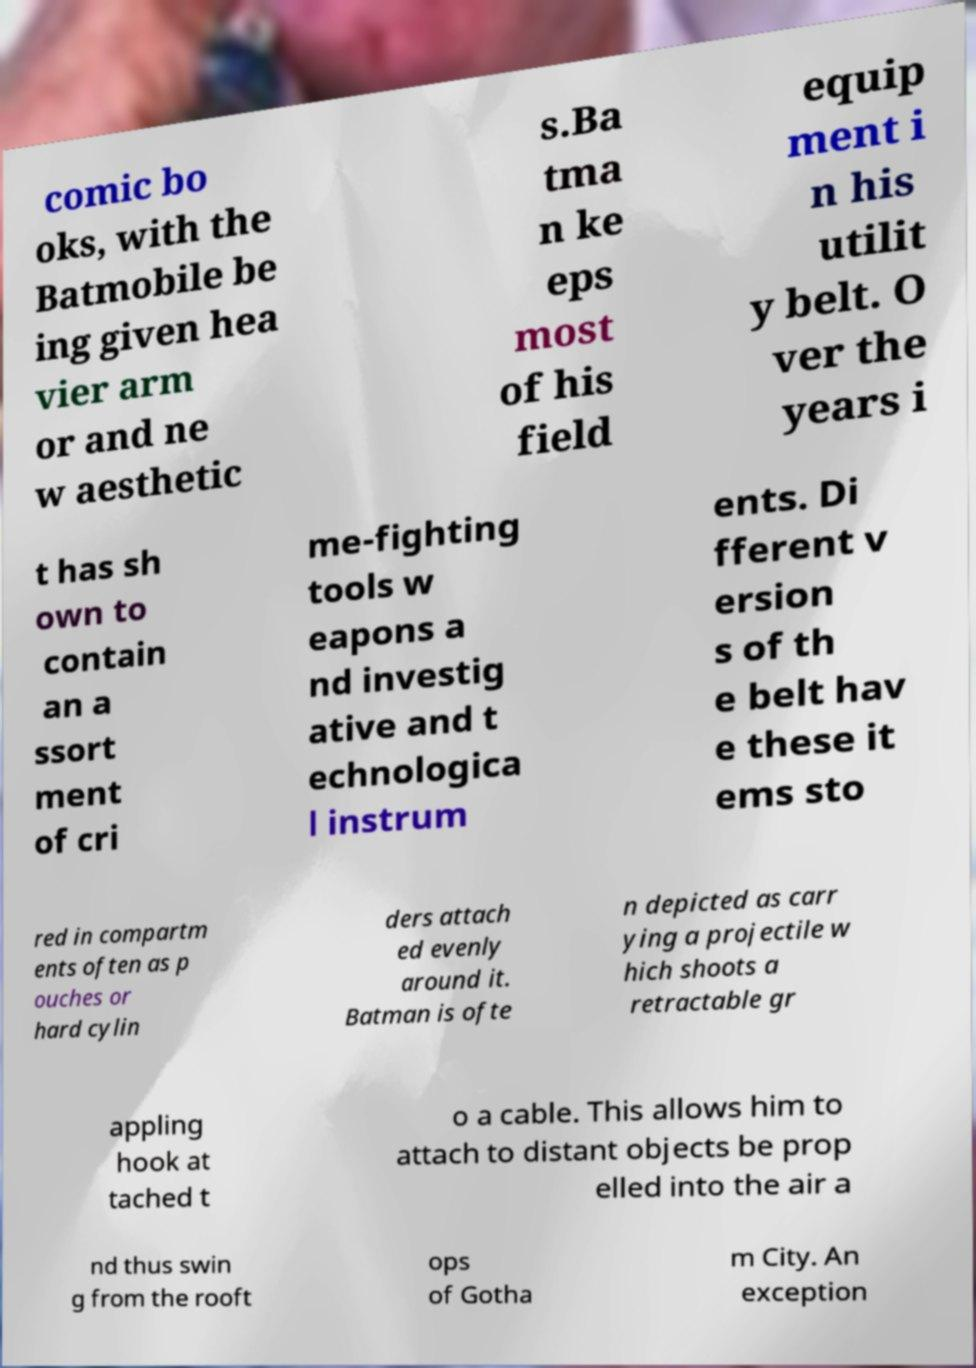Can you read and provide the text displayed in the image?This photo seems to have some interesting text. Can you extract and type it out for me? comic bo oks, with the Batmobile be ing given hea vier arm or and ne w aesthetic s.Ba tma n ke eps most of his field equip ment i n his utilit y belt. O ver the years i t has sh own to contain an a ssort ment of cri me-fighting tools w eapons a nd investig ative and t echnologica l instrum ents. Di fferent v ersion s of th e belt hav e these it ems sto red in compartm ents often as p ouches or hard cylin ders attach ed evenly around it. Batman is ofte n depicted as carr ying a projectile w hich shoots a retractable gr appling hook at tached t o a cable. This allows him to attach to distant objects be prop elled into the air a nd thus swin g from the rooft ops of Gotha m City. An exception 